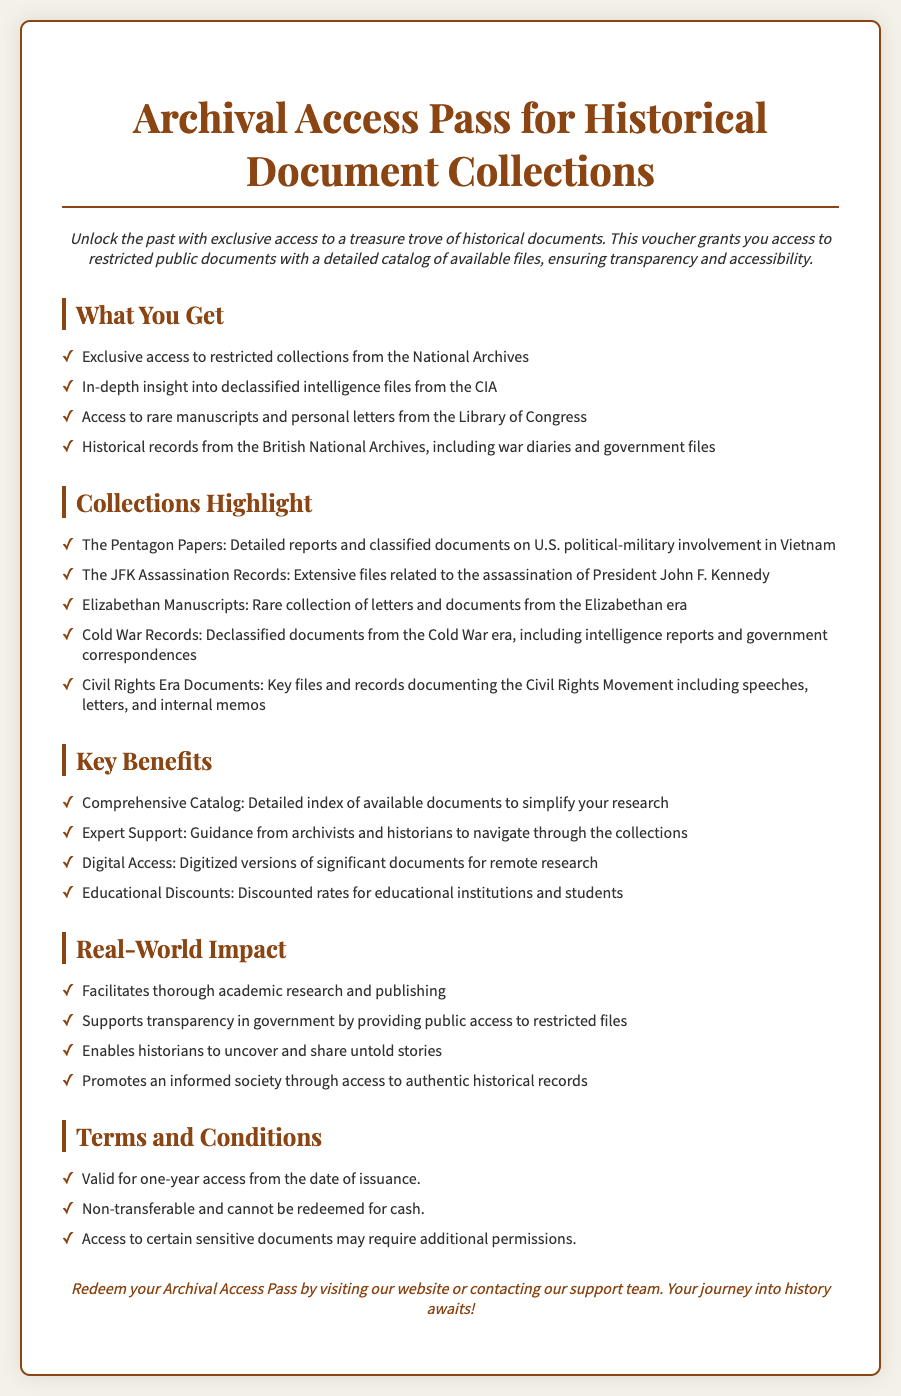What is the title of the voucher? The title of the voucher is located at the top of the document and states its purpose clearly.
Answer: Archival Access Pass for Historical Document Collections How long is the access period for the voucher? The duration of the access period is specified in the Terms and Conditions section of the document.
Answer: One-year What type of documents can be accessed from the National Archives? This is mentioned in the 'What You Get' section, outlining the types of documents available.
Answer: Restricted collections What is one highlighted collection available with this pass? The collections highlighted in the document include notable historical documents.
Answer: The Pentagon Papers What benefit is provided for educational institutions? This benefit addresses specific groups entitled to reduced pricing within the Key Benefits section.
Answer: Educational Discounts How many key benefits are listed in the document? The number of benefits can be determined by counting the items in the Key Benefits section.
Answer: Four What important social movement is documented in the collections? The collections relate to a significant historical movement mentioned under the Collections Highlight.
Answer: Civil Rights Movement What is the color used for text in the voucher? The color used for text is defined in the style section of the code, indicating the design choice for readability.
Answer: Dark brown 